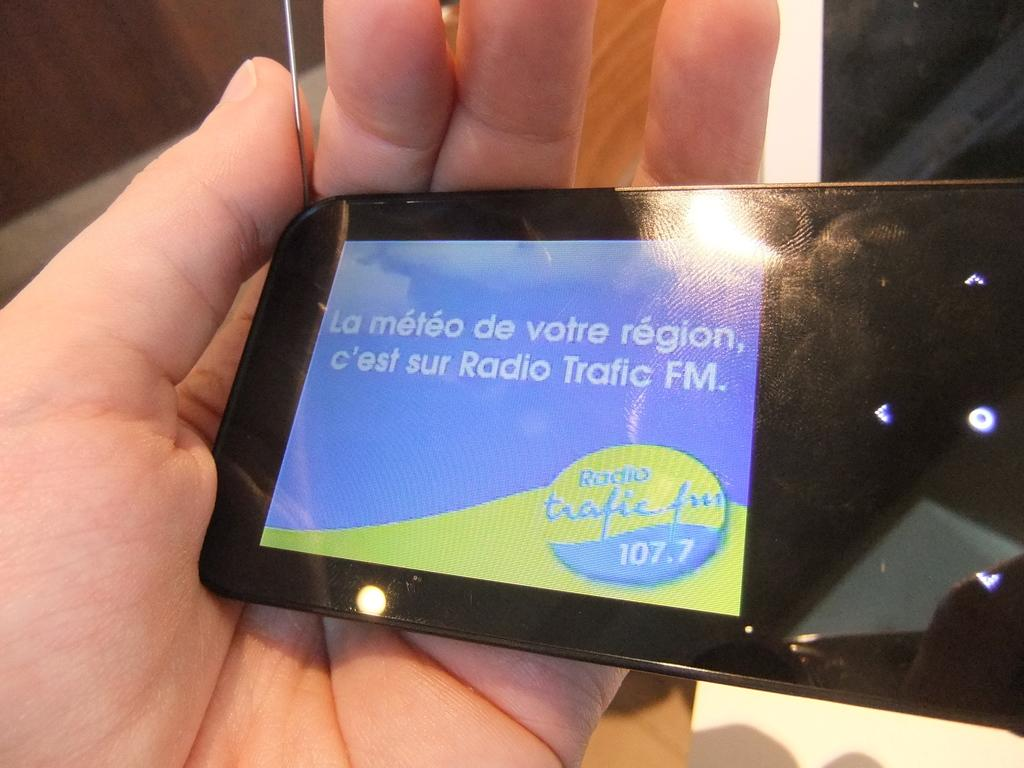<image>
Present a compact description of the photo's key features. A electronic device is showing the radio station 107.7 in a different language 